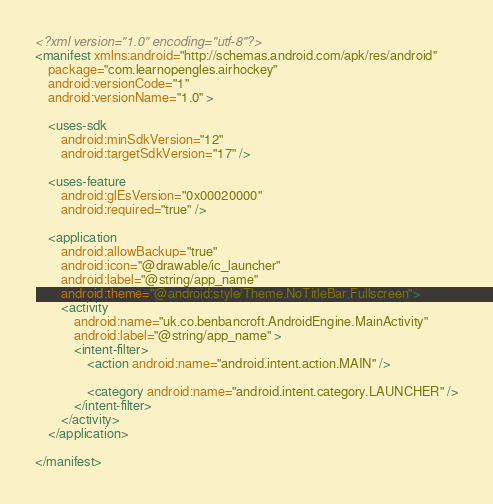Convert code to text. <code><loc_0><loc_0><loc_500><loc_500><_XML_><?xml version="1.0" encoding="utf-8"?>
<manifest xmlns:android="http://schemas.android.com/apk/res/android"
    package="com.learnopengles.airhockey"
    android:versionCode="1"
    android:versionName="1.0" >

    <uses-sdk
        android:minSdkVersion="12"
        android:targetSdkVersion="17" />

    <uses-feature
        android:glEsVersion="0x00020000"
        android:required="true" />

    <application
        android:allowBackup="true"
        android:icon="@drawable/ic_launcher"
        android:label="@string/app_name"
        android:theme="@android:style/Theme.NoTitleBar.Fullscreen">
        <activity
            android:name="uk.co.benbancroft.AndroidEngine.MainActivity"
            android:label="@string/app_name" >
            <intent-filter>
                <action android:name="android.intent.action.MAIN" />

                <category android:name="android.intent.category.LAUNCHER" />
            </intent-filter>
        </activity>
    </application>

</manifest></code> 